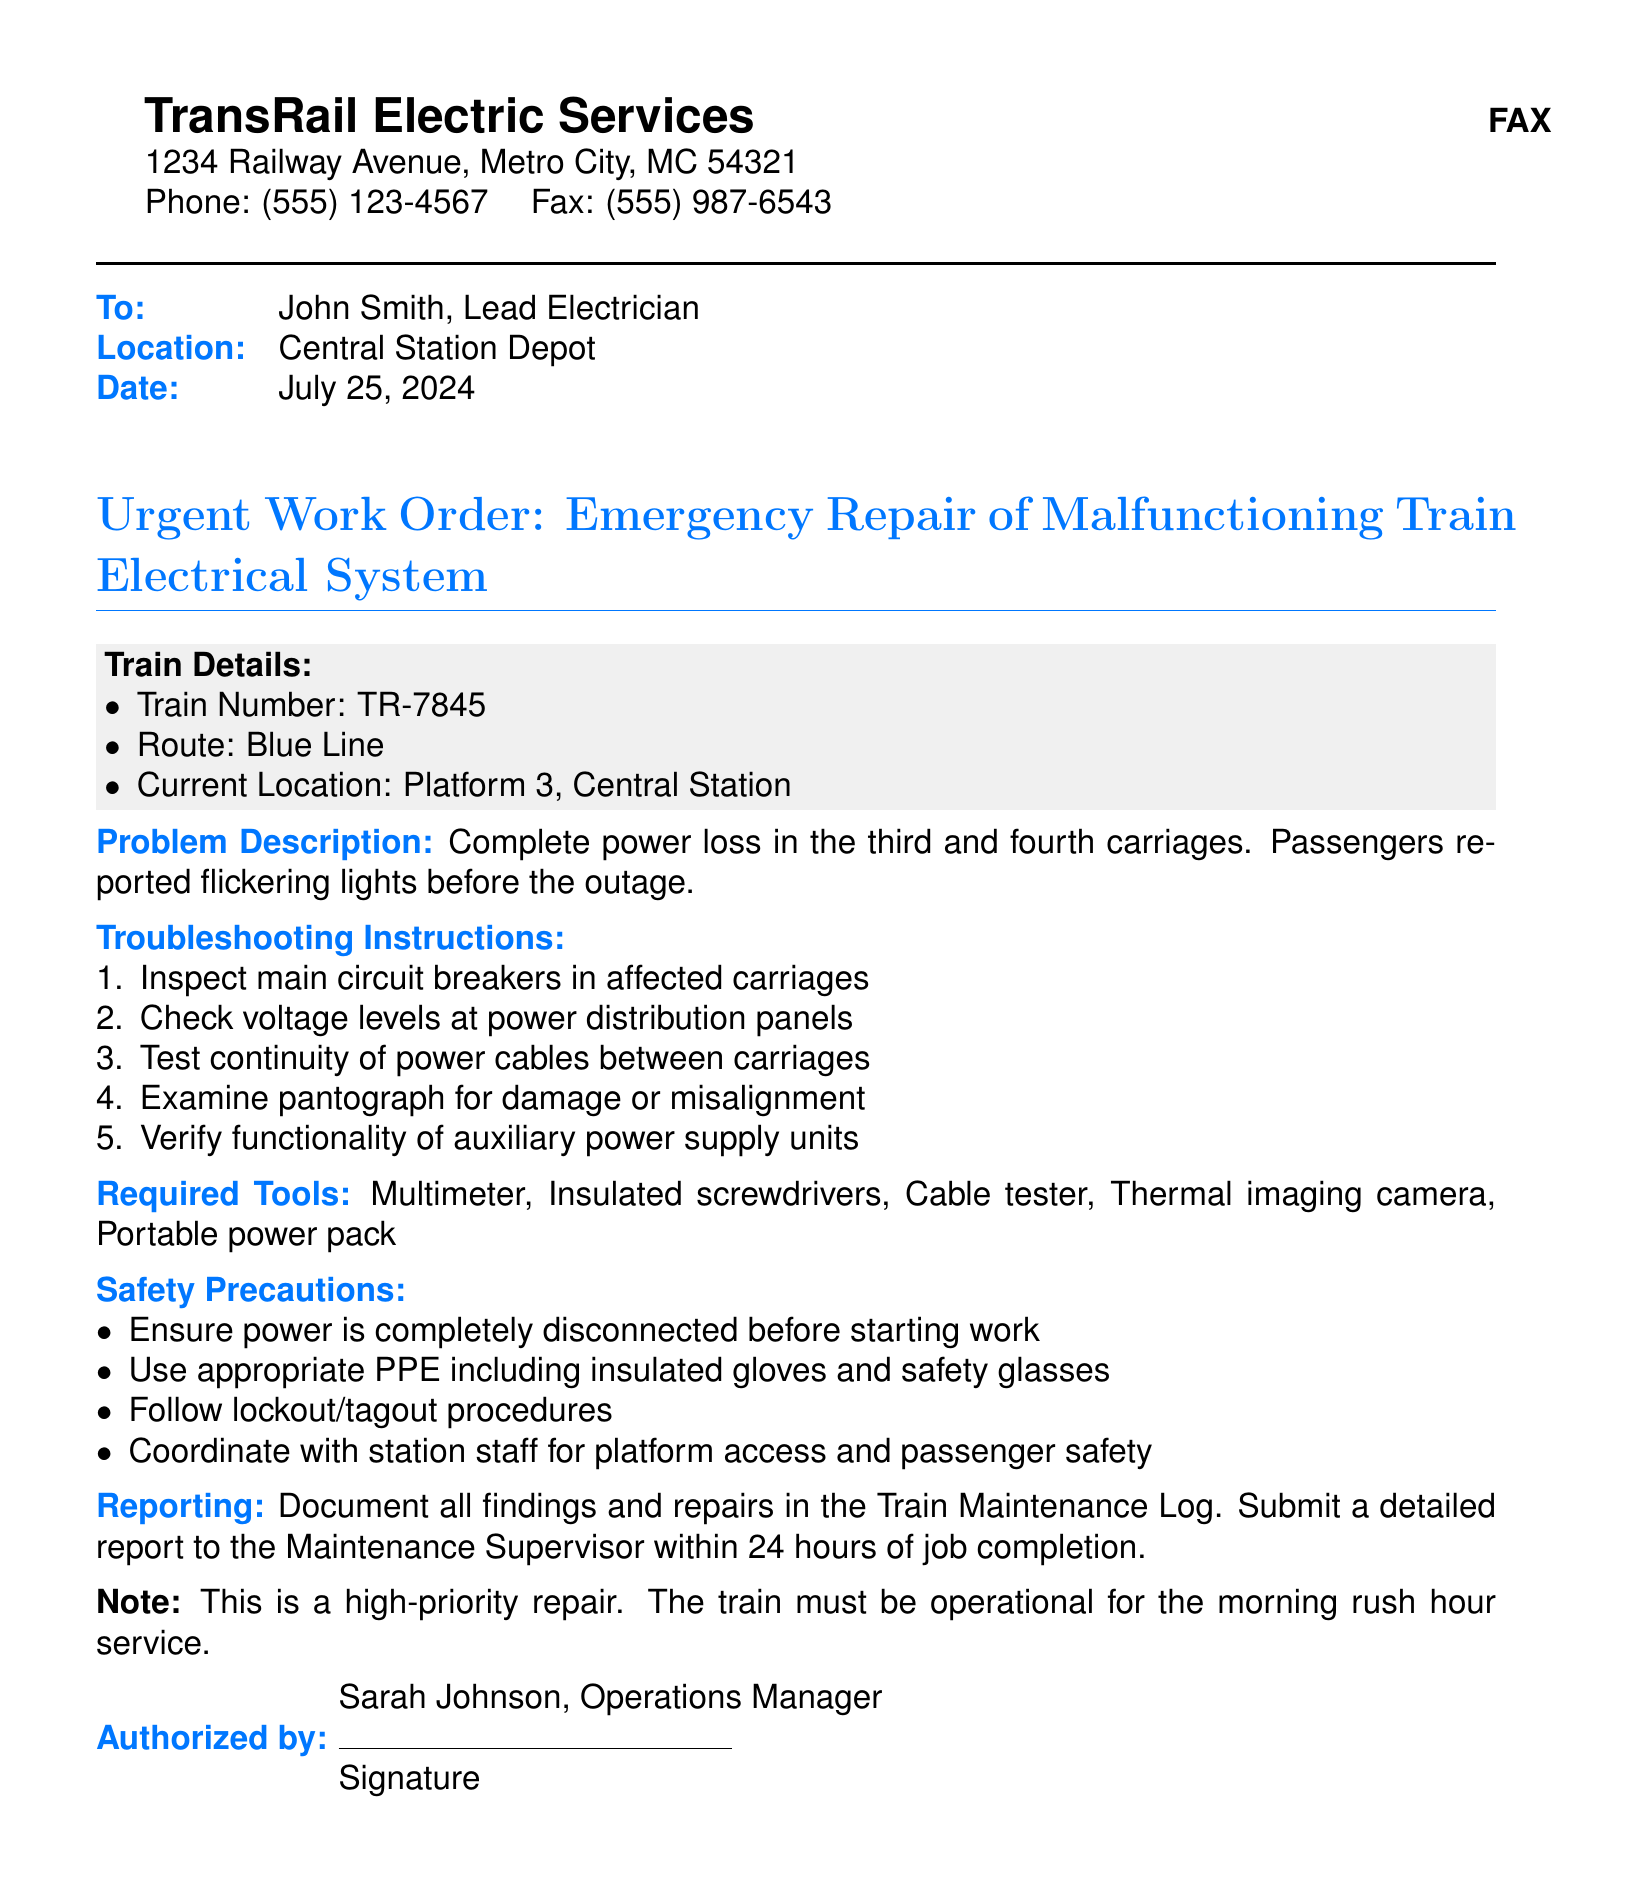What is the train number? The train number is specified in the document under Train Details.
Answer: TR-7845 What is the current location of the train? The location of the train is provided in the Train Details section of the document.
Answer: Platform 3, Central Station What is the problem description? The problem description is listed clearly in the document regarding the electrical issue.
Answer: Complete power loss in the third and fourth carriages What are the first troubleshooting instructions? The first item in the troubleshooting list indicates initial steps to take for the repair.
Answer: Inspect main circuit breakers in affected carriages What tools are required for the repair? A list of required tools is given in the document for this particular repair task.
Answer: Multimeter, Insulated screwdrivers, Cable tester, Thermal imaging camera, Portable power pack Who is the authorized person for this work order? The document specifies the individual who authorized the work at the end of the message.
Answer: Sarah Johnson What safety precautions should be taken? Safety measures are outlined in the document to ensure proper safety while working.
Answer: Ensure power is completely disconnected before starting work What is the urgency level of this repair? The document emphasizes the importance of urgency related to the train's operation schedule.
Answer: High-priority When should the detailed report be submitted? The document specifies the timeline for submitting the report after job completion.
Answer: Within 24 hours of job completion 